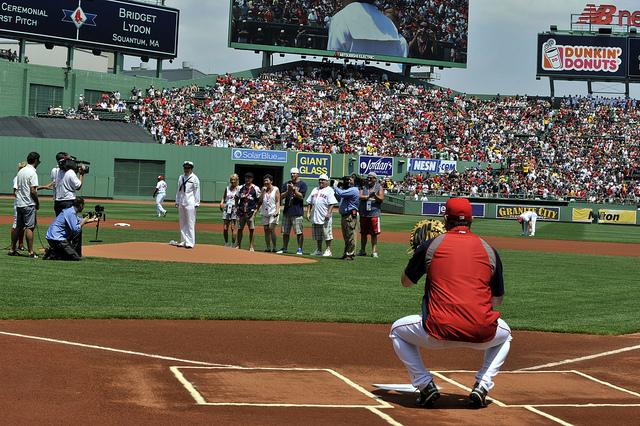What type of pitch is this?

Choices:
A) fastball
B) ceremonial pitch
C) knuckleball
D) forkball ceremonial pitch 